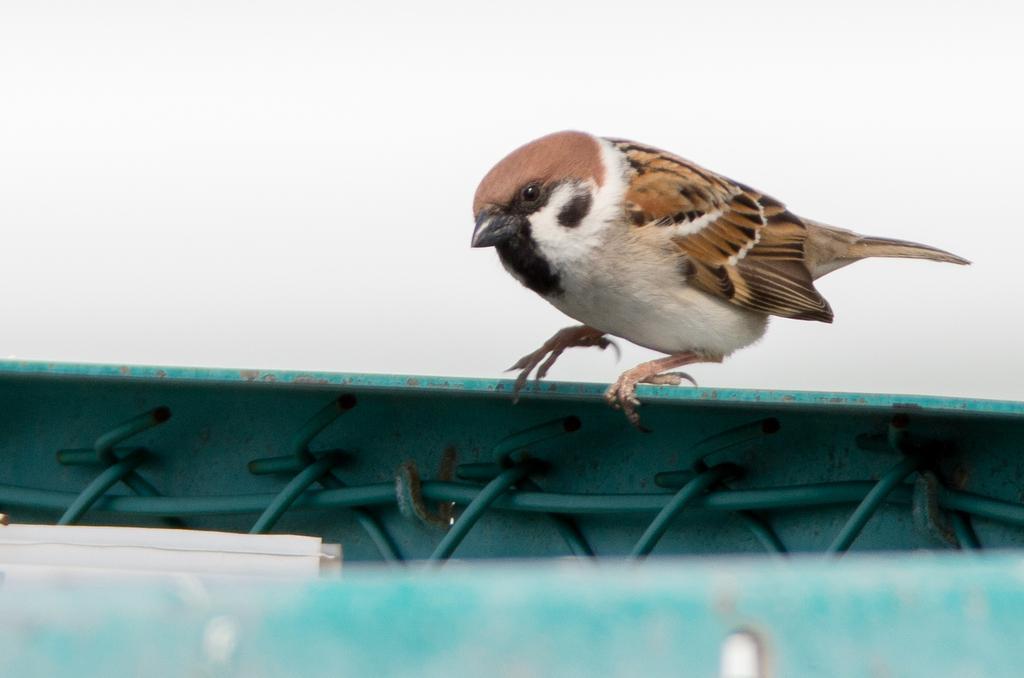Can you describe this image briefly? This image consists of a sparrow in brown color. At the bottom, we can see a fencing. At the top, there is sky. 